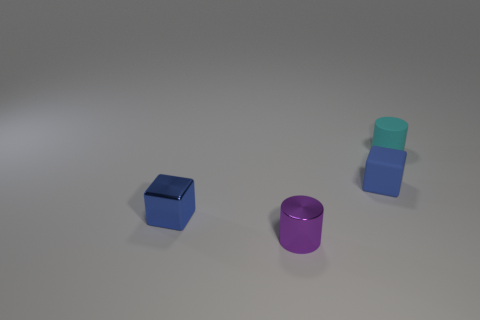How big is the thing that is behind the purple metal cylinder and left of the tiny rubber cube?
Your response must be concise. Small. The cyan object that is the same size as the purple metallic cylinder is what shape?
Your response must be concise. Cylinder. What color is the other thing that is the same material as the cyan thing?
Provide a succinct answer. Blue. What material is the other small block that is the same color as the matte cube?
Offer a terse response. Metal. What number of objects are either small purple objects or small red metal spheres?
Provide a succinct answer. 1. What size is the purple object that is the same shape as the cyan object?
Your response must be concise. Small. Are there any other things that have the same size as the cyan matte cylinder?
Make the answer very short. Yes. How many other objects are the same color as the small rubber cylinder?
Keep it short and to the point. 0. What number of spheres are either small metallic things or big yellow metal things?
Your response must be concise. 0. The matte thing in front of the cylinder right of the blue rubber thing is what color?
Your answer should be compact. Blue. 